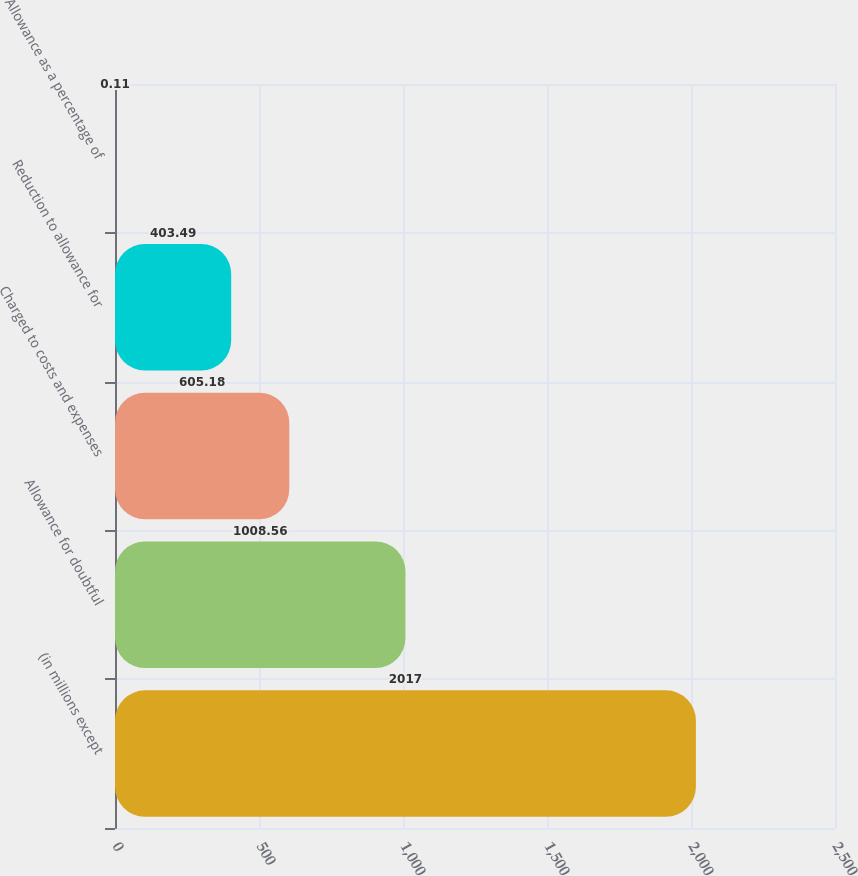Convert chart. <chart><loc_0><loc_0><loc_500><loc_500><bar_chart><fcel>(in millions except<fcel>Allowance for doubtful<fcel>Charged to costs and expenses<fcel>Reduction to allowance for<fcel>Allowance as a percentage of<nl><fcel>2017<fcel>1008.56<fcel>605.18<fcel>403.49<fcel>0.11<nl></chart> 